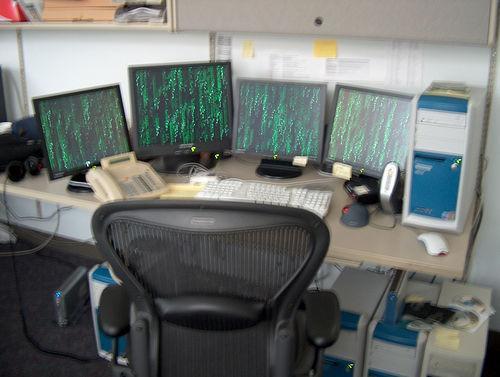How many monitors do you see?
Give a very brief answer. 4. 